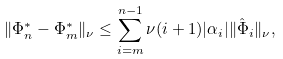<formula> <loc_0><loc_0><loc_500><loc_500>\| \Phi _ { n } ^ { * } - \Phi _ { m } ^ { * } \| _ { \nu } \leq \sum _ { i = m } ^ { n - 1 } \nu ( i + 1 ) | \alpha _ { i } | \| \hat { \Phi } _ { i } \| _ { \nu } ,</formula> 